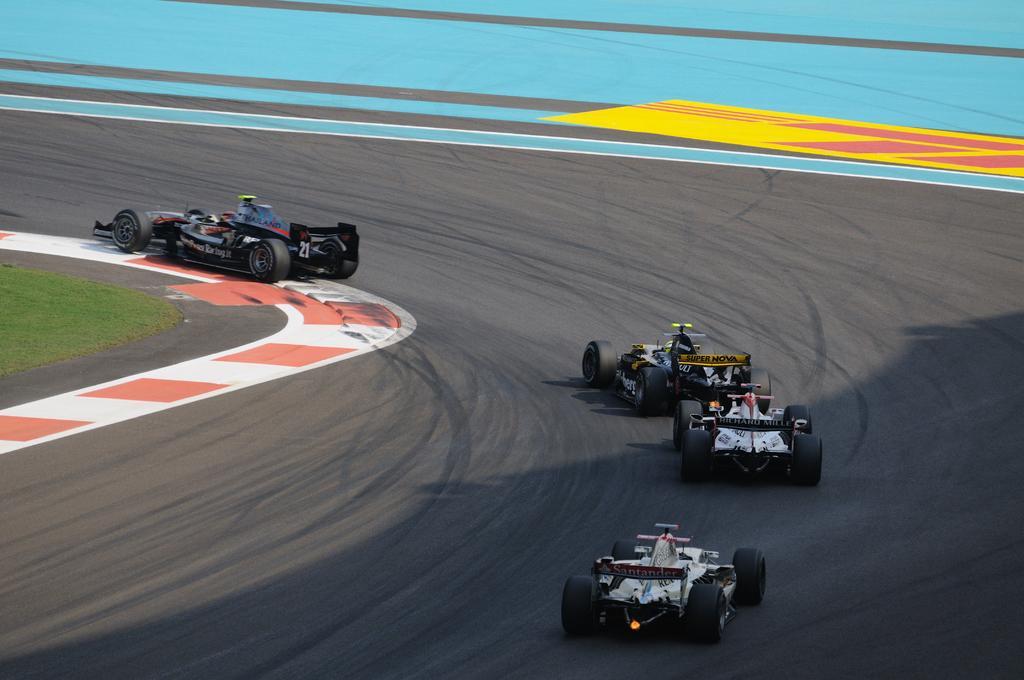How would you summarize this image in a sentence or two? In the image we can see four cars on the road. This is a road and grass. 